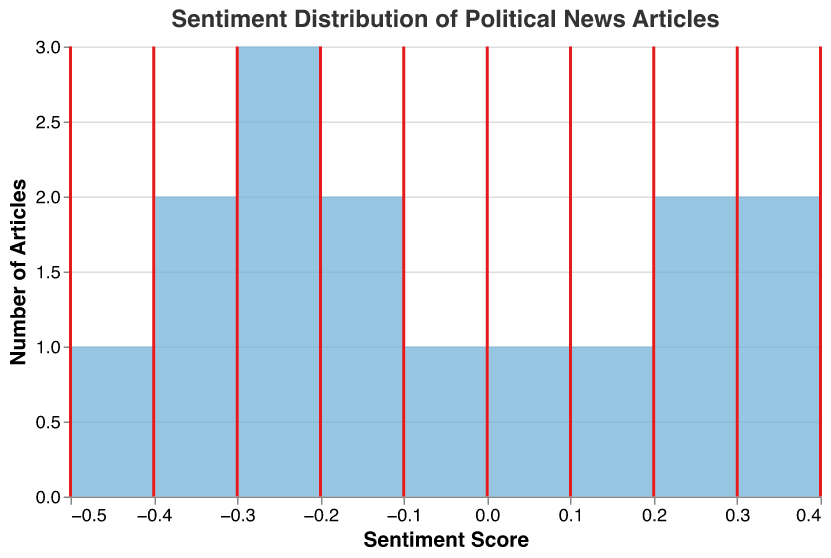What's the title of the plot? The title of the plot is displayed at the top center of the figure. It is "Sentiment Distribution of Political News Articles."
Answer: Sentiment Distribution of Political News Articles What does the x-axis represent? The x-axis of the plot represents the sentiment scores of the news articles. The sentiment scores are quantitative values that range from negative to positive.
Answer: Sentiment Score What does the y-axis represent? The y-axis of the plot represents the number of articles corresponding to a particular sentiment score range. It aggregates the count of articles for each bin of sentiment scores.
Answer: Number of Articles Which sentiment score range has the highest count of articles? By observing the height of the bars, we see that the bin around the sentiment score range of -0.2 has the highest count of articles.
Answer: -0.2 What is the color of the bars in the plot? The bars in the plot are colored light blue.
Answer: light blue Where is the mean sentiment score located, and how is it represented? The mean sentiment score is represented by a vertical red line. It is a rule mark in the plot.
Answer: A vertical red line What is the mean sentiment score of the articles? The mean sentiment score can be found by looking at the tooltip that appears when hovering over the vertical red line. It gives an exact value as the mean of all sentiment scores. Based on the provided code, this value can be approximated from the distribution and tooltip.
Answer: ~ -0.133 How many articles have a neutral sentiment score of 0? The bar at the sentiment score of 0 represents the count of neutral articles. From the plot, we observe that there is 1 article with a sentiment score of 0.
Answer: 1 How does the number of articles with negative sentiment compare to those with positive sentiment? To compare, count the number of articles for all negative sentiment scores and compare them with the count for all positive sentiment scores. The bars for negative sentiment scores are more numerous and have higher counts than those for positive sentiment scores.
Answer: More articles have negative sentiment than positive sentiment What can be inferred about the general sentiment of the political news articles? Observing the distribution and the mean sentiment indicated by the red line, we see that the distribution is slightly skewed towards negative sentiment. Additionally, the majority of the articles fall in the negative sentiment range.
Answer: Generally negative 